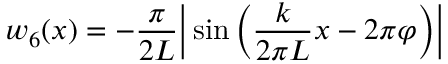Convert formula to latex. <formula><loc_0><loc_0><loc_500><loc_500>w _ { 6 } ( x ) = - \frac { \pi } { 2 L } \left | \sin \left ( \frac { k } { 2 \pi L } x - 2 \pi \varphi \right ) \right |</formula> 